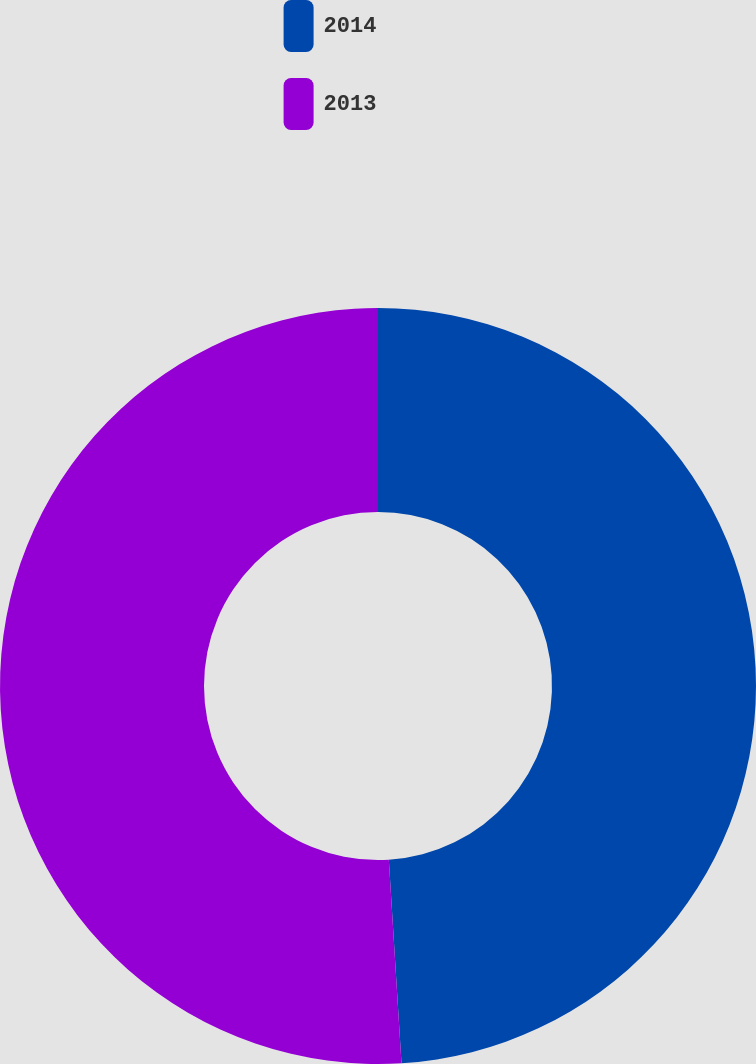<chart> <loc_0><loc_0><loc_500><loc_500><pie_chart><fcel>2014<fcel>2013<nl><fcel>49.01%<fcel>50.99%<nl></chart> 